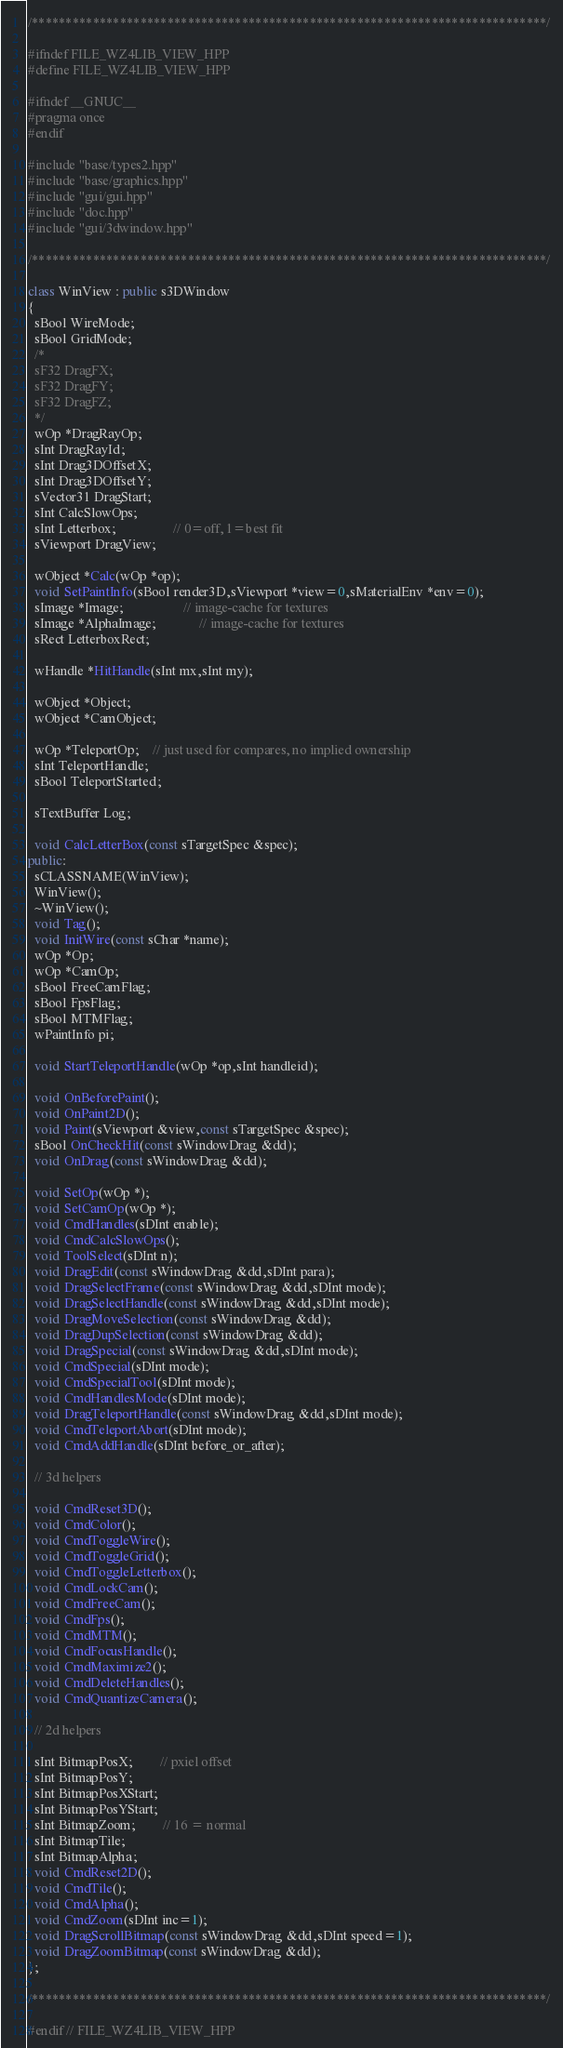<code> <loc_0><loc_0><loc_500><loc_500><_C++_>/****************************************************************************/

#ifndef FILE_WZ4LIB_VIEW_HPP
#define FILE_WZ4LIB_VIEW_HPP

#ifndef __GNUC__
#pragma once
#endif

#include "base/types2.hpp"
#include "base/graphics.hpp"
#include "gui/gui.hpp"
#include "doc.hpp"
#include "gui/3dwindow.hpp"

/****************************************************************************/

class WinView : public s3DWindow
{
  sBool WireMode;
  sBool GridMode;
  /*
  sF32 DragFX;
  sF32 DragFY;
  sF32 DragFZ;
  */
  wOp *DragRayOp;
  sInt DragRayId;
  sInt Drag3DOffsetX;
  sInt Drag3DOffsetY;
  sVector31 DragStart;
  sInt CalcSlowOps;
  sInt Letterbox;                 // 0=off, 1=best fit
  sViewport DragView;

  wObject *Calc(wOp *op);
  void SetPaintInfo(sBool render3D,sViewport *view=0,sMaterialEnv *env=0);
  sImage *Image;                  // image-cache for textures
  sImage *AlphaImage;             // image-cache for textures
  sRect LetterboxRect;

  wHandle *HitHandle(sInt mx,sInt my);

  wObject *Object;
  wObject *CamObject;

  wOp *TeleportOp;    // just used for compares, no implied ownership
  sInt TeleportHandle;
  sBool TeleportStarted;

  sTextBuffer Log;

  void CalcLetterBox(const sTargetSpec &spec);
public:
  sCLASSNAME(WinView);
  WinView();
  ~WinView();
  void Tag();
  void InitWire(const sChar *name);
  wOp *Op;
  wOp *CamOp;
  sBool FreeCamFlag;
  sBool FpsFlag;
  sBool MTMFlag;
  wPaintInfo pi;

  void StartTeleportHandle(wOp *op,sInt handleid);

  void OnBeforePaint();
  void OnPaint2D();
  void Paint(sViewport &view,const sTargetSpec &spec);
  sBool OnCheckHit(const sWindowDrag &dd);
  void OnDrag(const sWindowDrag &dd);
  
  void SetOp(wOp *);
  void SetCamOp(wOp *);
  void CmdHandles(sDInt enable);
  void CmdCalcSlowOps();
  void ToolSelect(sDInt n);
  void DragEdit(const sWindowDrag &dd,sDInt para);
  void DragSelectFrame(const sWindowDrag &dd,sDInt mode);
  void DragSelectHandle(const sWindowDrag &dd,sDInt mode);
  void DragMoveSelection(const sWindowDrag &dd);
  void DragDupSelection(const sWindowDrag &dd);
  void DragSpecial(const sWindowDrag &dd,sDInt mode);
  void CmdSpecial(sDInt mode);
  void CmdSpecialTool(sDInt mode);
  void CmdHandlesMode(sDInt mode);
  void DragTeleportHandle(const sWindowDrag &dd,sDInt mode);
  void CmdTeleportAbort(sDInt mode);
  void CmdAddHandle(sDInt before_or_after);

  // 3d helpers

  void CmdReset3D();
  void CmdColor();
  void CmdToggleWire();
  void CmdToggleGrid();
  void CmdToggleLetterbox();
  void CmdLockCam();
  void CmdFreeCam();
  void CmdFps();
  void CmdMTM();
  void CmdFocusHandle();
  void CmdMaximize2();
  void CmdDeleteHandles();
  void CmdQuantizeCamera();

  // 2d helpers

  sInt BitmapPosX;        // pxiel offset
  sInt BitmapPosY;
  sInt BitmapPosXStart;
  sInt BitmapPosYStart;
  sInt BitmapZoom;        // 16 = normal
  sInt BitmapTile;
  sInt BitmapAlpha;
  void CmdReset2D();
  void CmdTile();
  void CmdAlpha();
  void CmdZoom(sDInt inc=1);
  void DragScrollBitmap(const sWindowDrag &dd,sDInt speed=1);
  void DragZoomBitmap(const sWindowDrag &dd);
};

/****************************************************************************/

#endif // FILE_WZ4LIB_VIEW_HPP

</code> 